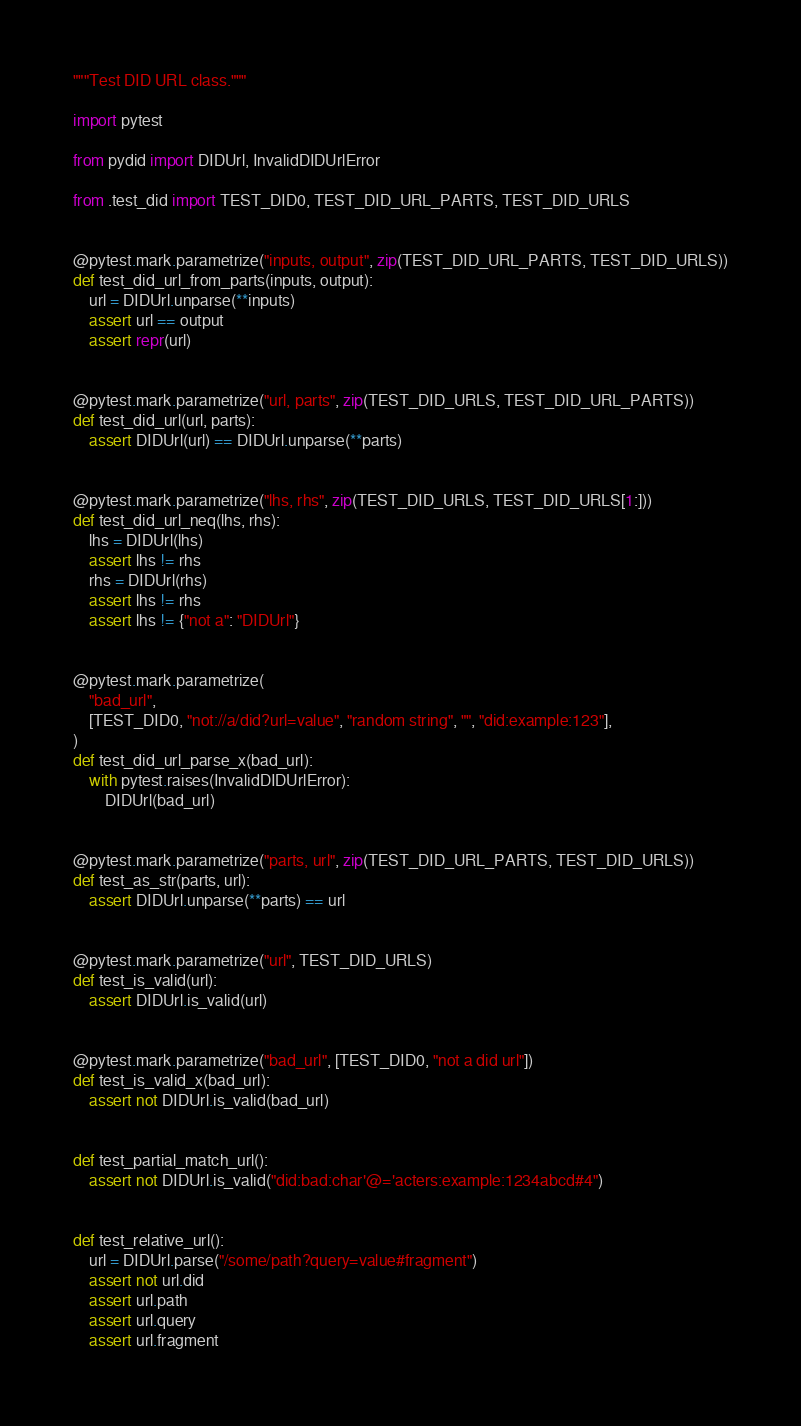<code> <loc_0><loc_0><loc_500><loc_500><_Python_>"""Test DID URL class."""

import pytest

from pydid import DIDUrl, InvalidDIDUrlError

from .test_did import TEST_DID0, TEST_DID_URL_PARTS, TEST_DID_URLS


@pytest.mark.parametrize("inputs, output", zip(TEST_DID_URL_PARTS, TEST_DID_URLS))
def test_did_url_from_parts(inputs, output):
    url = DIDUrl.unparse(**inputs)
    assert url == output
    assert repr(url)


@pytest.mark.parametrize("url, parts", zip(TEST_DID_URLS, TEST_DID_URL_PARTS))
def test_did_url(url, parts):
    assert DIDUrl(url) == DIDUrl.unparse(**parts)


@pytest.mark.parametrize("lhs, rhs", zip(TEST_DID_URLS, TEST_DID_URLS[1:]))
def test_did_url_neq(lhs, rhs):
    lhs = DIDUrl(lhs)
    assert lhs != rhs
    rhs = DIDUrl(rhs)
    assert lhs != rhs
    assert lhs != {"not a": "DIDUrl"}


@pytest.mark.parametrize(
    "bad_url",
    [TEST_DID0, "not://a/did?url=value", "random string", "", "did:example:123"],
)
def test_did_url_parse_x(bad_url):
    with pytest.raises(InvalidDIDUrlError):
        DIDUrl(bad_url)


@pytest.mark.parametrize("parts, url", zip(TEST_DID_URL_PARTS, TEST_DID_URLS))
def test_as_str(parts, url):
    assert DIDUrl.unparse(**parts) == url


@pytest.mark.parametrize("url", TEST_DID_URLS)
def test_is_valid(url):
    assert DIDUrl.is_valid(url)


@pytest.mark.parametrize("bad_url", [TEST_DID0, "not a did url"])
def test_is_valid_x(bad_url):
    assert not DIDUrl.is_valid(bad_url)


def test_partial_match_url():
    assert not DIDUrl.is_valid("did:bad:char'@='acters:example:1234abcd#4")


def test_relative_url():
    url = DIDUrl.parse("/some/path?query=value#fragment")
    assert not url.did
    assert url.path
    assert url.query
    assert url.fragment
</code> 